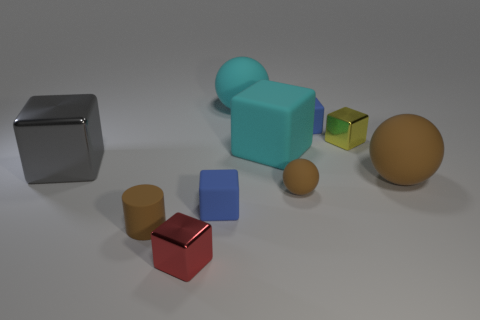Is there any significance to the colors of the objects in this image? While the colors of the objects may not convey a particular significance, they provide a clear contrast that could be useful for distinguishing different elements in a compositional or educational context, such as a visualization in color theory or to clarify spatial orientation. Could these colors help in visual tracking or computer vision tests? Certainly, the varied colors could serve as markers or points of interest in computer vision algorithms, used to test object recognition, tracking capabilities, and even depth perception by analyzing the colors' interaction with light and shadows. 